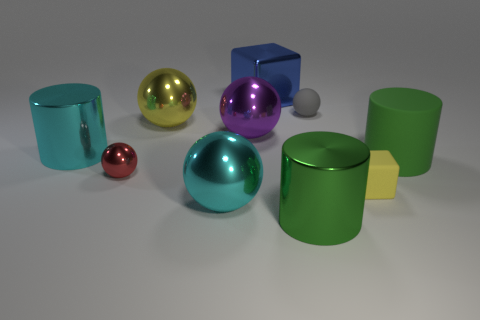Is the number of green cylinders that are behind the green shiny cylinder the same as the number of gray spheres?
Give a very brief answer. Yes. Is the material of the large cylinder that is in front of the yellow rubber cube the same as the thing behind the small gray ball?
Keep it short and to the point. Yes. The tiny rubber thing in front of the shiny cylinder that is to the left of the big blue shiny thing is what shape?
Your answer should be very brief. Cube. There is a big cube that is made of the same material as the small red object; what color is it?
Offer a very short reply. Blue. The green matte object that is the same size as the green metallic cylinder is what shape?
Provide a succinct answer. Cylinder. The green metal cylinder has what size?
Give a very brief answer. Large. Do the cylinder that is in front of the tiny yellow matte thing and the yellow thing that is to the left of the blue shiny cube have the same size?
Provide a short and direct response. Yes. What color is the shiny cylinder that is behind the green cylinder behind the small red object?
Provide a succinct answer. Cyan. There is a gray thing that is the same size as the red metal sphere; what is it made of?
Provide a succinct answer. Rubber. How many matte objects are either tiny gray things or cyan spheres?
Provide a short and direct response. 1. 